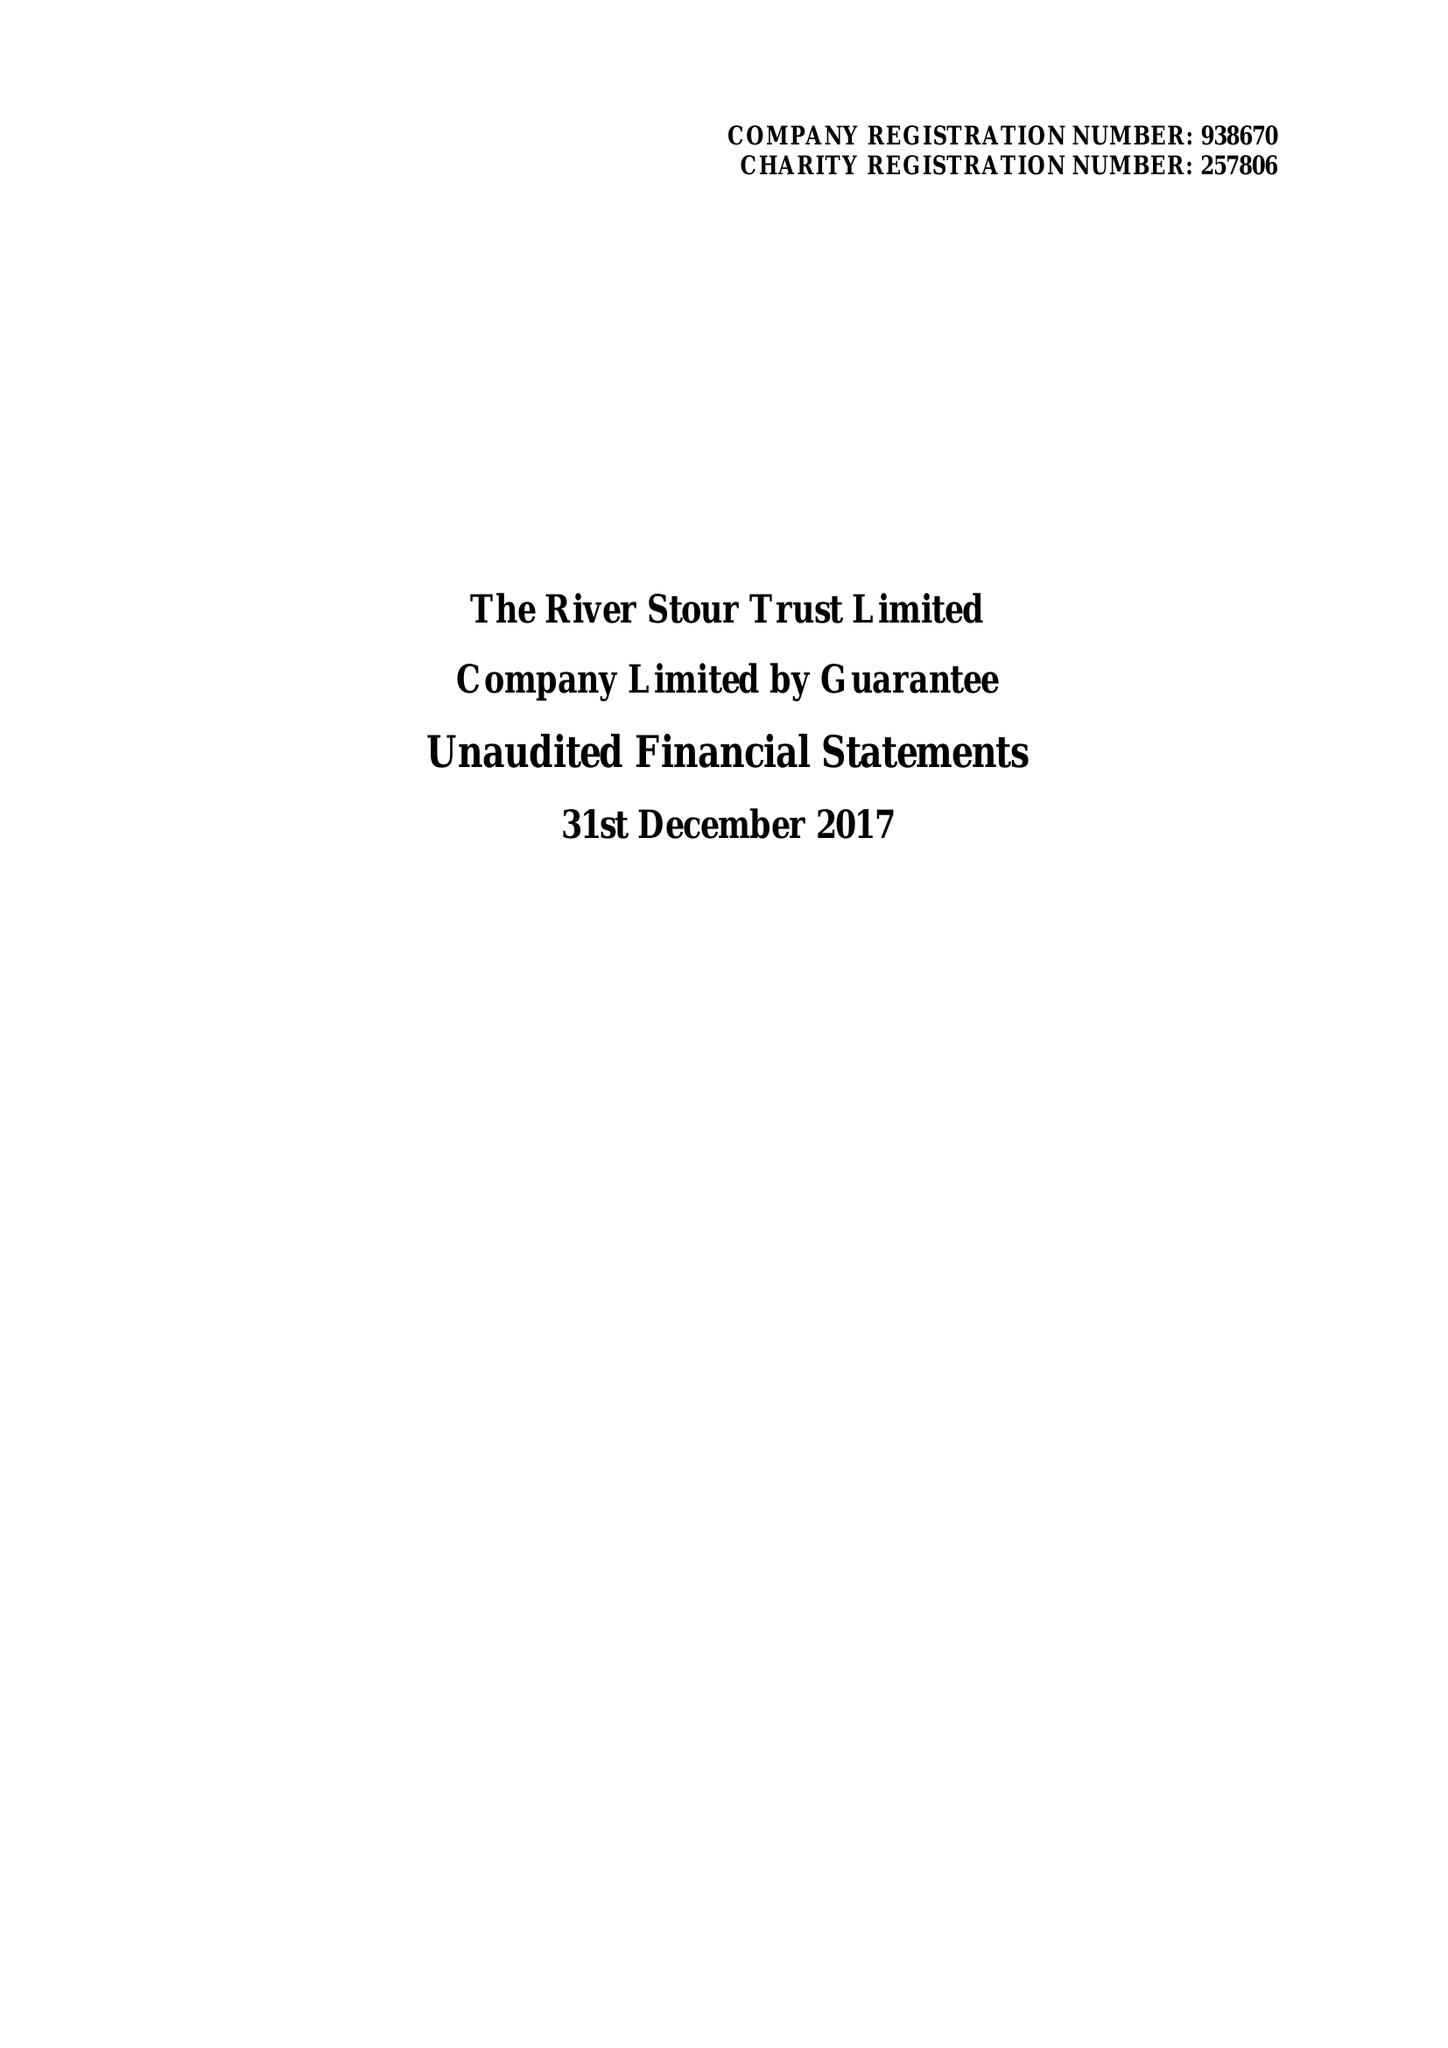What is the value for the spending_annually_in_british_pounds?
Answer the question using a single word or phrase. 118110.00 